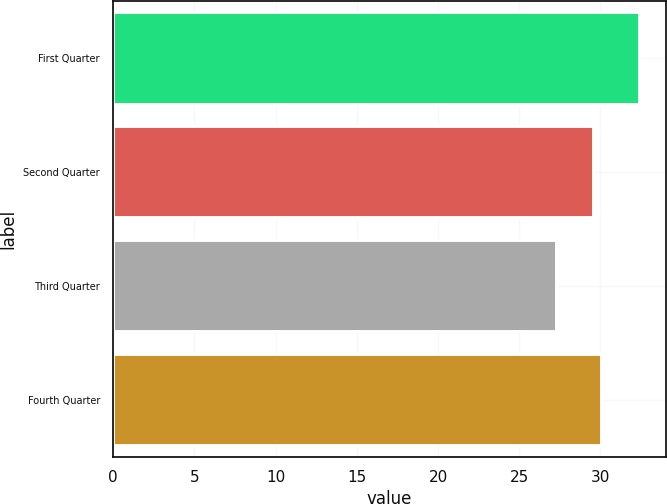Convert chart. <chart><loc_0><loc_0><loc_500><loc_500><bar_chart><fcel>First Quarter<fcel>Second Quarter<fcel>Third Quarter<fcel>Fourth Quarter<nl><fcel>32.4<fcel>29.54<fcel>27.26<fcel>30.05<nl></chart> 